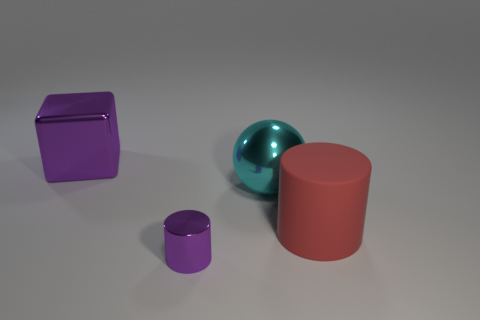Are there an equal number of metal things that are in front of the rubber thing and purple metal blocks?
Your answer should be very brief. Yes. There is a cyan shiny object; is it the same size as the metal object behind the large cyan object?
Give a very brief answer. Yes. What number of other objects are there of the same size as the purple metallic cylinder?
Provide a succinct answer. 0. How many other things are the same color as the large cube?
Your answer should be compact. 1. Is there any other thing that has the same size as the purple cylinder?
Keep it short and to the point. No. What number of other objects are there of the same shape as the big red thing?
Your response must be concise. 1. Is the rubber cylinder the same size as the cyan sphere?
Offer a terse response. Yes. Is there a yellow cylinder?
Your answer should be very brief. No. Is there any other thing that has the same material as the big cylinder?
Ensure brevity in your answer.  No. Are there any cyan objects made of the same material as the cube?
Offer a very short reply. Yes. 